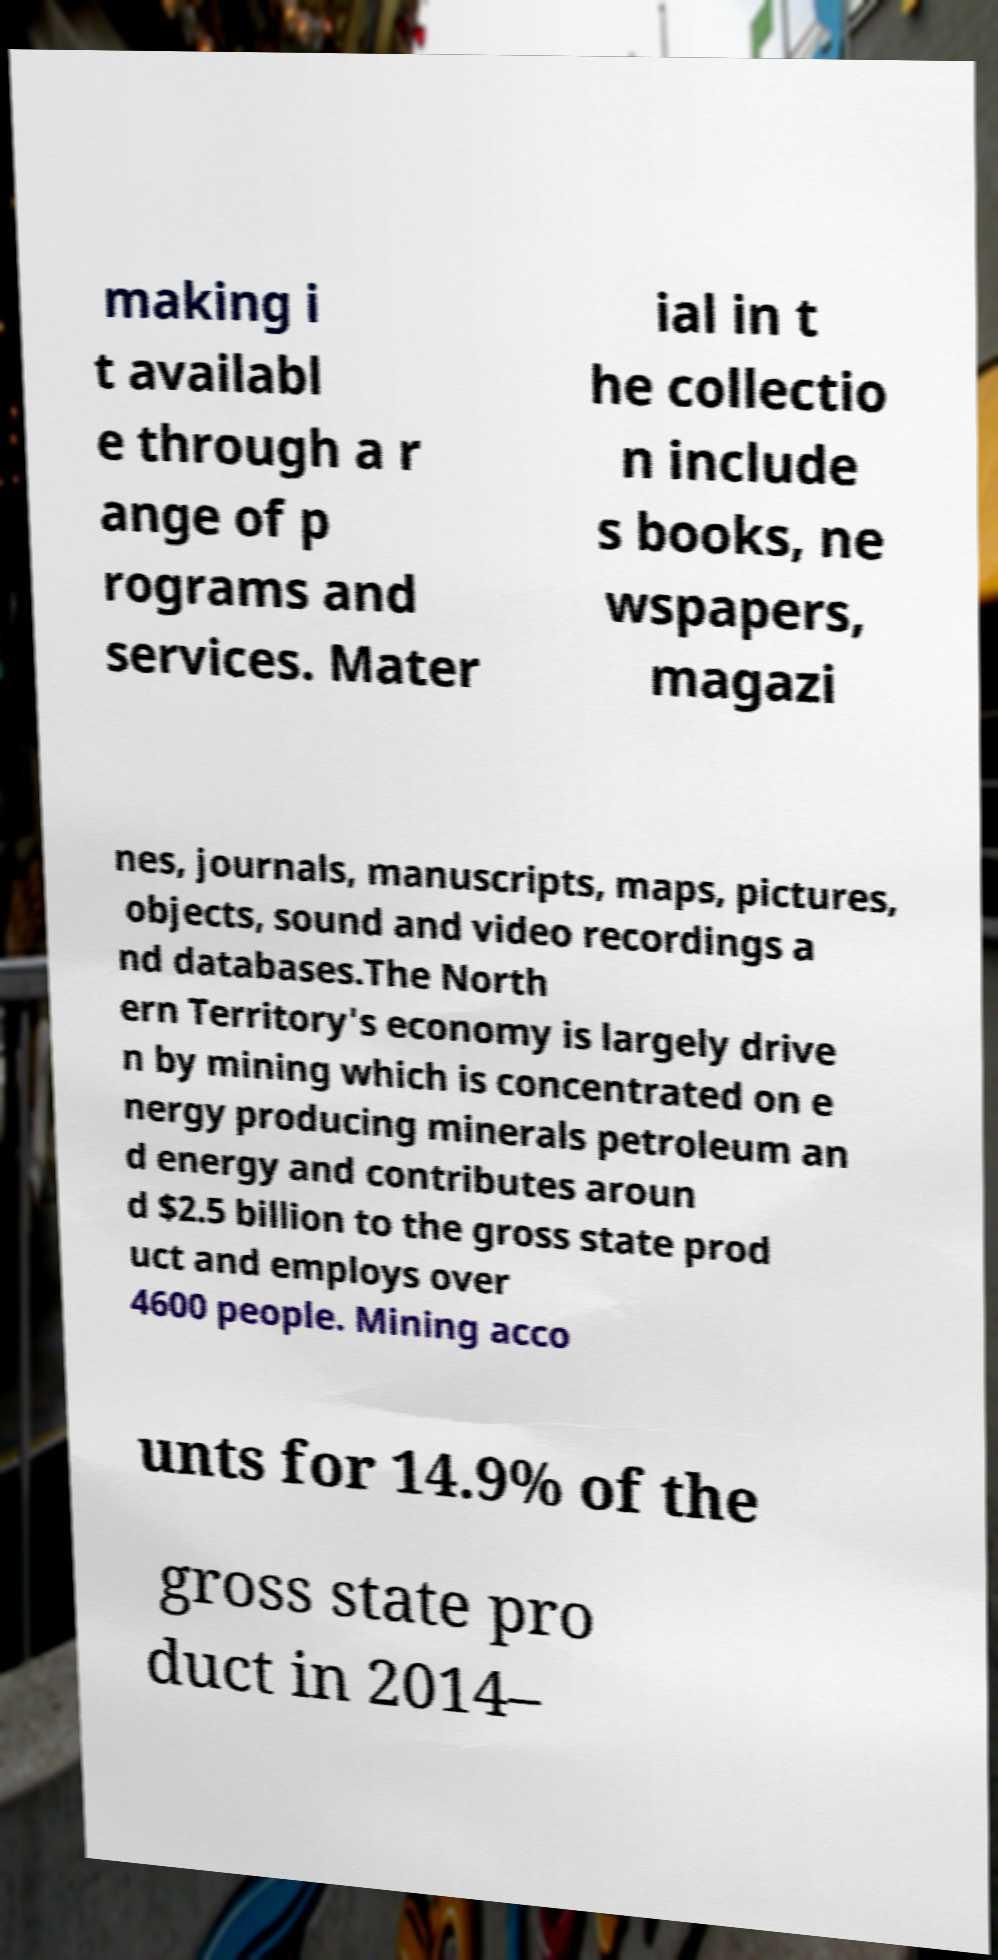Could you assist in decoding the text presented in this image and type it out clearly? making i t availabl e through a r ange of p rograms and services. Mater ial in t he collectio n include s books, ne wspapers, magazi nes, journals, manuscripts, maps, pictures, objects, sound and video recordings a nd databases.The North ern Territory's economy is largely drive n by mining which is concentrated on e nergy producing minerals petroleum an d energy and contributes aroun d $2.5 billion to the gross state prod uct and employs over 4600 people. Mining acco unts for 14.9% of the gross state pro duct in 2014– 